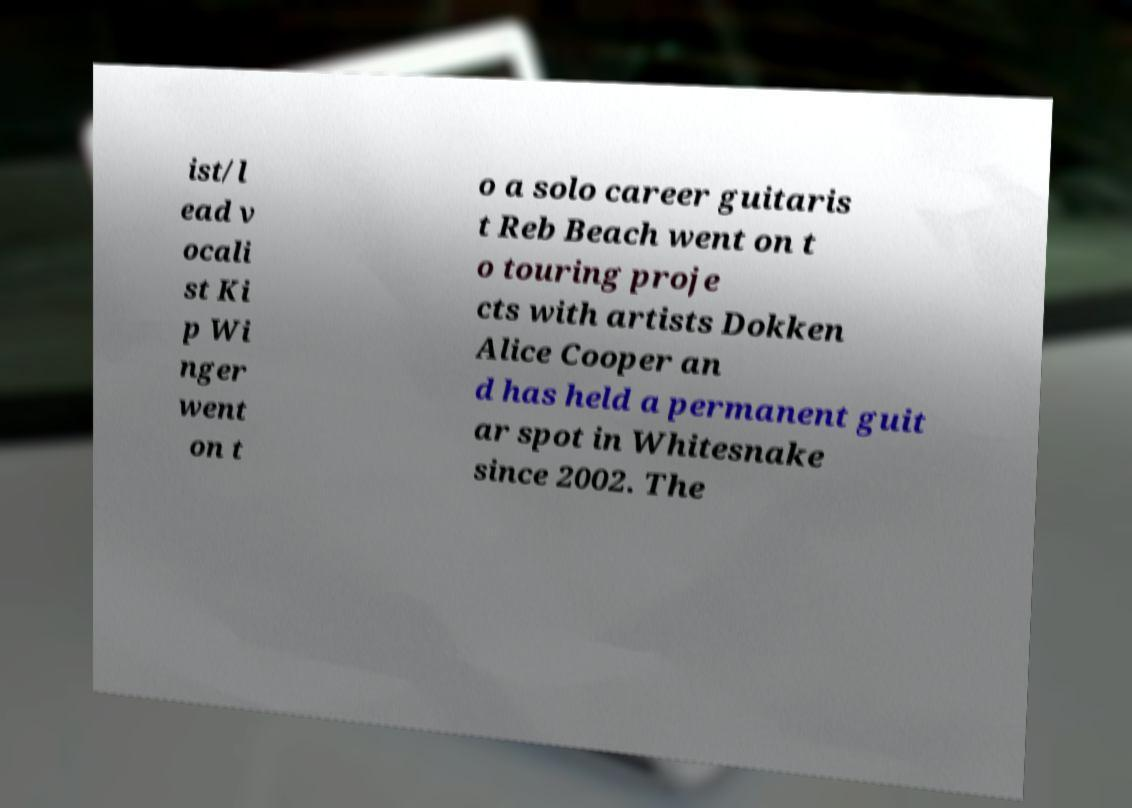Could you extract and type out the text from this image? ist/l ead v ocali st Ki p Wi nger went on t o a solo career guitaris t Reb Beach went on t o touring proje cts with artists Dokken Alice Cooper an d has held a permanent guit ar spot in Whitesnake since 2002. The 